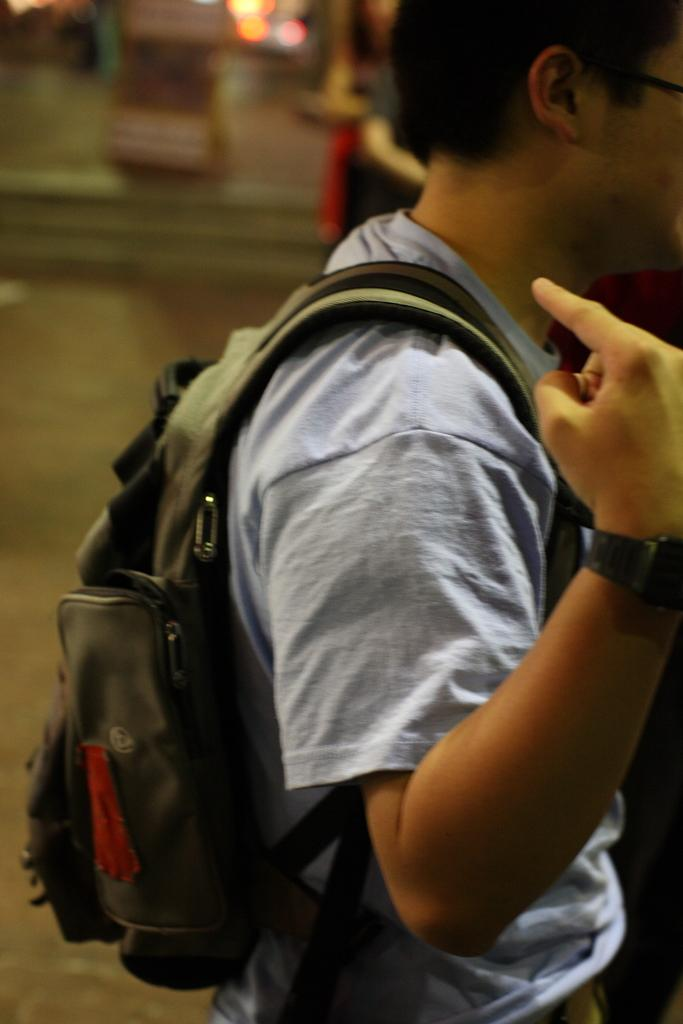What is the person in the image holding? The person is holding a book and a cup of coffee. What object is on the table in the image? There is a laptop on the table. What can be seen in the background of the image? There is a window and a plant in the background of the image. What type of sand can be seen on the list in the image? There is no sand or list present in the image. 